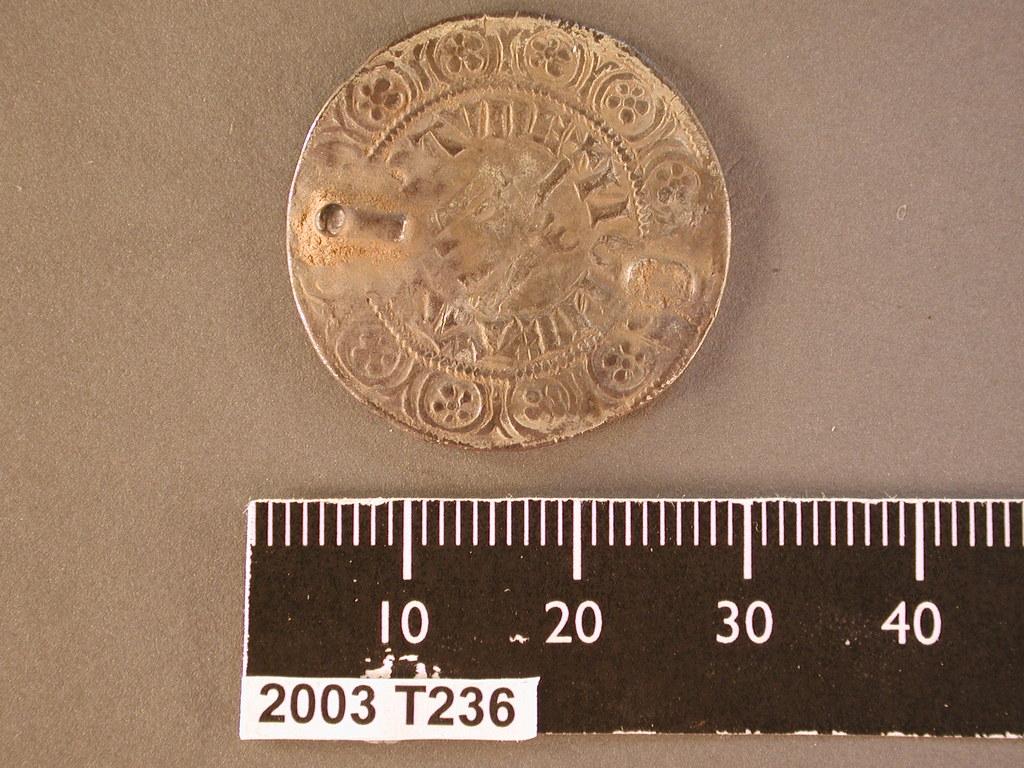What is the first number on the ruler?
Offer a terse response. 10. 